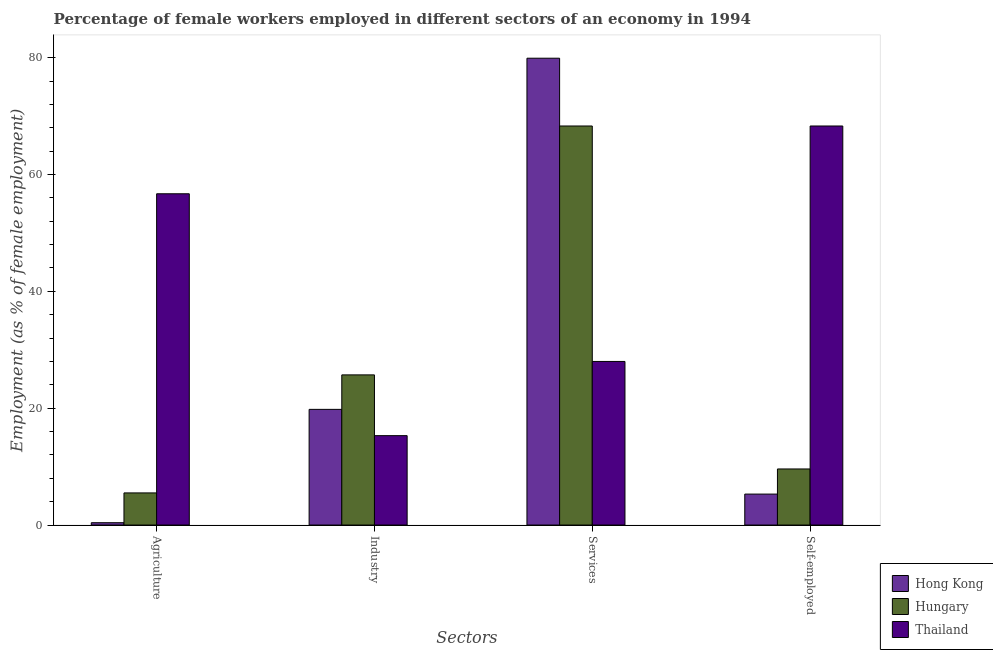How many different coloured bars are there?
Your answer should be very brief. 3. How many groups of bars are there?
Give a very brief answer. 4. Are the number of bars on each tick of the X-axis equal?
Provide a short and direct response. Yes. What is the label of the 2nd group of bars from the left?
Offer a very short reply. Industry. What is the percentage of female workers in services in Hungary?
Offer a terse response. 68.3. Across all countries, what is the maximum percentage of self employed female workers?
Offer a terse response. 68.3. Across all countries, what is the minimum percentage of female workers in agriculture?
Offer a terse response. 0.4. In which country was the percentage of self employed female workers maximum?
Your answer should be very brief. Thailand. In which country was the percentage of female workers in services minimum?
Offer a very short reply. Thailand. What is the total percentage of female workers in industry in the graph?
Ensure brevity in your answer.  60.8. What is the difference between the percentage of female workers in agriculture in Thailand and that in Hungary?
Give a very brief answer. 51.2. What is the difference between the percentage of self employed female workers in Thailand and the percentage of female workers in agriculture in Hong Kong?
Your response must be concise. 67.9. What is the average percentage of female workers in industry per country?
Ensure brevity in your answer.  20.27. What is the difference between the percentage of female workers in industry and percentage of female workers in services in Hungary?
Your answer should be compact. -42.6. In how many countries, is the percentage of self employed female workers greater than 64 %?
Offer a terse response. 1. What is the ratio of the percentage of female workers in agriculture in Hungary to that in Thailand?
Offer a very short reply. 0.1. Is the difference between the percentage of female workers in industry in Hong Kong and Hungary greater than the difference between the percentage of female workers in agriculture in Hong Kong and Hungary?
Provide a short and direct response. No. What is the difference between the highest and the second highest percentage of female workers in agriculture?
Give a very brief answer. 51.2. What is the difference between the highest and the lowest percentage of female workers in agriculture?
Give a very brief answer. 56.3. Is it the case that in every country, the sum of the percentage of female workers in services and percentage of female workers in agriculture is greater than the sum of percentage of self employed female workers and percentage of female workers in industry?
Make the answer very short. Yes. What does the 3rd bar from the left in Industry represents?
Ensure brevity in your answer.  Thailand. What does the 2nd bar from the right in Services represents?
Your response must be concise. Hungary. Is it the case that in every country, the sum of the percentage of female workers in agriculture and percentage of female workers in industry is greater than the percentage of female workers in services?
Provide a short and direct response. No. Are all the bars in the graph horizontal?
Offer a very short reply. No. How many countries are there in the graph?
Your answer should be very brief. 3. Does the graph contain any zero values?
Keep it short and to the point. No. Does the graph contain grids?
Your answer should be compact. No. How many legend labels are there?
Ensure brevity in your answer.  3. How are the legend labels stacked?
Your answer should be compact. Vertical. What is the title of the graph?
Ensure brevity in your answer.  Percentage of female workers employed in different sectors of an economy in 1994. What is the label or title of the X-axis?
Make the answer very short. Sectors. What is the label or title of the Y-axis?
Make the answer very short. Employment (as % of female employment). What is the Employment (as % of female employment) of Hong Kong in Agriculture?
Provide a succinct answer. 0.4. What is the Employment (as % of female employment) of Hungary in Agriculture?
Your response must be concise. 5.5. What is the Employment (as % of female employment) in Thailand in Agriculture?
Ensure brevity in your answer.  56.7. What is the Employment (as % of female employment) of Hong Kong in Industry?
Offer a terse response. 19.8. What is the Employment (as % of female employment) in Hungary in Industry?
Your answer should be very brief. 25.7. What is the Employment (as % of female employment) in Thailand in Industry?
Your response must be concise. 15.3. What is the Employment (as % of female employment) in Hong Kong in Services?
Your answer should be compact. 79.9. What is the Employment (as % of female employment) of Hungary in Services?
Offer a very short reply. 68.3. What is the Employment (as % of female employment) of Thailand in Services?
Ensure brevity in your answer.  28. What is the Employment (as % of female employment) of Hong Kong in Self-employed?
Keep it short and to the point. 5.3. What is the Employment (as % of female employment) in Hungary in Self-employed?
Ensure brevity in your answer.  9.6. What is the Employment (as % of female employment) of Thailand in Self-employed?
Provide a short and direct response. 68.3. Across all Sectors, what is the maximum Employment (as % of female employment) in Hong Kong?
Give a very brief answer. 79.9. Across all Sectors, what is the maximum Employment (as % of female employment) in Hungary?
Provide a succinct answer. 68.3. Across all Sectors, what is the maximum Employment (as % of female employment) of Thailand?
Your response must be concise. 68.3. Across all Sectors, what is the minimum Employment (as % of female employment) of Hong Kong?
Your response must be concise. 0.4. Across all Sectors, what is the minimum Employment (as % of female employment) in Thailand?
Your answer should be compact. 15.3. What is the total Employment (as % of female employment) in Hong Kong in the graph?
Provide a short and direct response. 105.4. What is the total Employment (as % of female employment) in Hungary in the graph?
Keep it short and to the point. 109.1. What is the total Employment (as % of female employment) of Thailand in the graph?
Keep it short and to the point. 168.3. What is the difference between the Employment (as % of female employment) of Hong Kong in Agriculture and that in Industry?
Your answer should be compact. -19.4. What is the difference between the Employment (as % of female employment) in Hungary in Agriculture and that in Industry?
Keep it short and to the point. -20.2. What is the difference between the Employment (as % of female employment) in Thailand in Agriculture and that in Industry?
Offer a terse response. 41.4. What is the difference between the Employment (as % of female employment) of Hong Kong in Agriculture and that in Services?
Keep it short and to the point. -79.5. What is the difference between the Employment (as % of female employment) of Hungary in Agriculture and that in Services?
Offer a terse response. -62.8. What is the difference between the Employment (as % of female employment) of Thailand in Agriculture and that in Services?
Your answer should be very brief. 28.7. What is the difference between the Employment (as % of female employment) of Thailand in Agriculture and that in Self-employed?
Ensure brevity in your answer.  -11.6. What is the difference between the Employment (as % of female employment) in Hong Kong in Industry and that in Services?
Keep it short and to the point. -60.1. What is the difference between the Employment (as % of female employment) of Hungary in Industry and that in Services?
Provide a succinct answer. -42.6. What is the difference between the Employment (as % of female employment) in Thailand in Industry and that in Self-employed?
Make the answer very short. -53. What is the difference between the Employment (as % of female employment) in Hong Kong in Services and that in Self-employed?
Offer a terse response. 74.6. What is the difference between the Employment (as % of female employment) of Hungary in Services and that in Self-employed?
Give a very brief answer. 58.7. What is the difference between the Employment (as % of female employment) in Thailand in Services and that in Self-employed?
Ensure brevity in your answer.  -40.3. What is the difference between the Employment (as % of female employment) of Hong Kong in Agriculture and the Employment (as % of female employment) of Hungary in Industry?
Keep it short and to the point. -25.3. What is the difference between the Employment (as % of female employment) in Hong Kong in Agriculture and the Employment (as % of female employment) in Thailand in Industry?
Offer a very short reply. -14.9. What is the difference between the Employment (as % of female employment) of Hungary in Agriculture and the Employment (as % of female employment) of Thailand in Industry?
Offer a very short reply. -9.8. What is the difference between the Employment (as % of female employment) of Hong Kong in Agriculture and the Employment (as % of female employment) of Hungary in Services?
Provide a short and direct response. -67.9. What is the difference between the Employment (as % of female employment) in Hong Kong in Agriculture and the Employment (as % of female employment) in Thailand in Services?
Your answer should be very brief. -27.6. What is the difference between the Employment (as % of female employment) of Hungary in Agriculture and the Employment (as % of female employment) of Thailand in Services?
Offer a terse response. -22.5. What is the difference between the Employment (as % of female employment) of Hong Kong in Agriculture and the Employment (as % of female employment) of Hungary in Self-employed?
Keep it short and to the point. -9.2. What is the difference between the Employment (as % of female employment) in Hong Kong in Agriculture and the Employment (as % of female employment) in Thailand in Self-employed?
Your answer should be very brief. -67.9. What is the difference between the Employment (as % of female employment) in Hungary in Agriculture and the Employment (as % of female employment) in Thailand in Self-employed?
Offer a very short reply. -62.8. What is the difference between the Employment (as % of female employment) in Hong Kong in Industry and the Employment (as % of female employment) in Hungary in Services?
Offer a very short reply. -48.5. What is the difference between the Employment (as % of female employment) in Hong Kong in Industry and the Employment (as % of female employment) in Hungary in Self-employed?
Make the answer very short. 10.2. What is the difference between the Employment (as % of female employment) of Hong Kong in Industry and the Employment (as % of female employment) of Thailand in Self-employed?
Give a very brief answer. -48.5. What is the difference between the Employment (as % of female employment) of Hungary in Industry and the Employment (as % of female employment) of Thailand in Self-employed?
Offer a very short reply. -42.6. What is the difference between the Employment (as % of female employment) of Hong Kong in Services and the Employment (as % of female employment) of Hungary in Self-employed?
Make the answer very short. 70.3. What is the difference between the Employment (as % of female employment) in Hong Kong in Services and the Employment (as % of female employment) in Thailand in Self-employed?
Provide a short and direct response. 11.6. What is the average Employment (as % of female employment) in Hong Kong per Sectors?
Your answer should be compact. 26.35. What is the average Employment (as % of female employment) in Hungary per Sectors?
Give a very brief answer. 27.27. What is the average Employment (as % of female employment) in Thailand per Sectors?
Keep it short and to the point. 42.08. What is the difference between the Employment (as % of female employment) in Hong Kong and Employment (as % of female employment) in Hungary in Agriculture?
Make the answer very short. -5.1. What is the difference between the Employment (as % of female employment) in Hong Kong and Employment (as % of female employment) in Thailand in Agriculture?
Make the answer very short. -56.3. What is the difference between the Employment (as % of female employment) in Hungary and Employment (as % of female employment) in Thailand in Agriculture?
Ensure brevity in your answer.  -51.2. What is the difference between the Employment (as % of female employment) in Hong Kong and Employment (as % of female employment) in Thailand in Industry?
Make the answer very short. 4.5. What is the difference between the Employment (as % of female employment) in Hungary and Employment (as % of female employment) in Thailand in Industry?
Ensure brevity in your answer.  10.4. What is the difference between the Employment (as % of female employment) in Hong Kong and Employment (as % of female employment) in Hungary in Services?
Ensure brevity in your answer.  11.6. What is the difference between the Employment (as % of female employment) of Hong Kong and Employment (as % of female employment) of Thailand in Services?
Provide a succinct answer. 51.9. What is the difference between the Employment (as % of female employment) of Hungary and Employment (as % of female employment) of Thailand in Services?
Your answer should be compact. 40.3. What is the difference between the Employment (as % of female employment) in Hong Kong and Employment (as % of female employment) in Hungary in Self-employed?
Make the answer very short. -4.3. What is the difference between the Employment (as % of female employment) in Hong Kong and Employment (as % of female employment) in Thailand in Self-employed?
Provide a short and direct response. -63. What is the difference between the Employment (as % of female employment) of Hungary and Employment (as % of female employment) of Thailand in Self-employed?
Ensure brevity in your answer.  -58.7. What is the ratio of the Employment (as % of female employment) in Hong Kong in Agriculture to that in Industry?
Make the answer very short. 0.02. What is the ratio of the Employment (as % of female employment) of Hungary in Agriculture to that in Industry?
Offer a very short reply. 0.21. What is the ratio of the Employment (as % of female employment) in Thailand in Agriculture to that in Industry?
Keep it short and to the point. 3.71. What is the ratio of the Employment (as % of female employment) in Hong Kong in Agriculture to that in Services?
Keep it short and to the point. 0.01. What is the ratio of the Employment (as % of female employment) in Hungary in Agriculture to that in Services?
Offer a terse response. 0.08. What is the ratio of the Employment (as % of female employment) in Thailand in Agriculture to that in Services?
Your answer should be compact. 2.02. What is the ratio of the Employment (as % of female employment) in Hong Kong in Agriculture to that in Self-employed?
Your response must be concise. 0.08. What is the ratio of the Employment (as % of female employment) of Hungary in Agriculture to that in Self-employed?
Offer a terse response. 0.57. What is the ratio of the Employment (as % of female employment) in Thailand in Agriculture to that in Self-employed?
Give a very brief answer. 0.83. What is the ratio of the Employment (as % of female employment) of Hong Kong in Industry to that in Services?
Provide a short and direct response. 0.25. What is the ratio of the Employment (as % of female employment) of Hungary in Industry to that in Services?
Your answer should be very brief. 0.38. What is the ratio of the Employment (as % of female employment) in Thailand in Industry to that in Services?
Offer a very short reply. 0.55. What is the ratio of the Employment (as % of female employment) of Hong Kong in Industry to that in Self-employed?
Your response must be concise. 3.74. What is the ratio of the Employment (as % of female employment) of Hungary in Industry to that in Self-employed?
Give a very brief answer. 2.68. What is the ratio of the Employment (as % of female employment) of Thailand in Industry to that in Self-employed?
Keep it short and to the point. 0.22. What is the ratio of the Employment (as % of female employment) in Hong Kong in Services to that in Self-employed?
Give a very brief answer. 15.08. What is the ratio of the Employment (as % of female employment) in Hungary in Services to that in Self-employed?
Provide a short and direct response. 7.11. What is the ratio of the Employment (as % of female employment) in Thailand in Services to that in Self-employed?
Ensure brevity in your answer.  0.41. What is the difference between the highest and the second highest Employment (as % of female employment) in Hong Kong?
Offer a terse response. 60.1. What is the difference between the highest and the second highest Employment (as % of female employment) of Hungary?
Ensure brevity in your answer.  42.6. What is the difference between the highest and the lowest Employment (as % of female employment) of Hong Kong?
Your answer should be very brief. 79.5. What is the difference between the highest and the lowest Employment (as % of female employment) in Hungary?
Your response must be concise. 62.8. What is the difference between the highest and the lowest Employment (as % of female employment) of Thailand?
Make the answer very short. 53. 